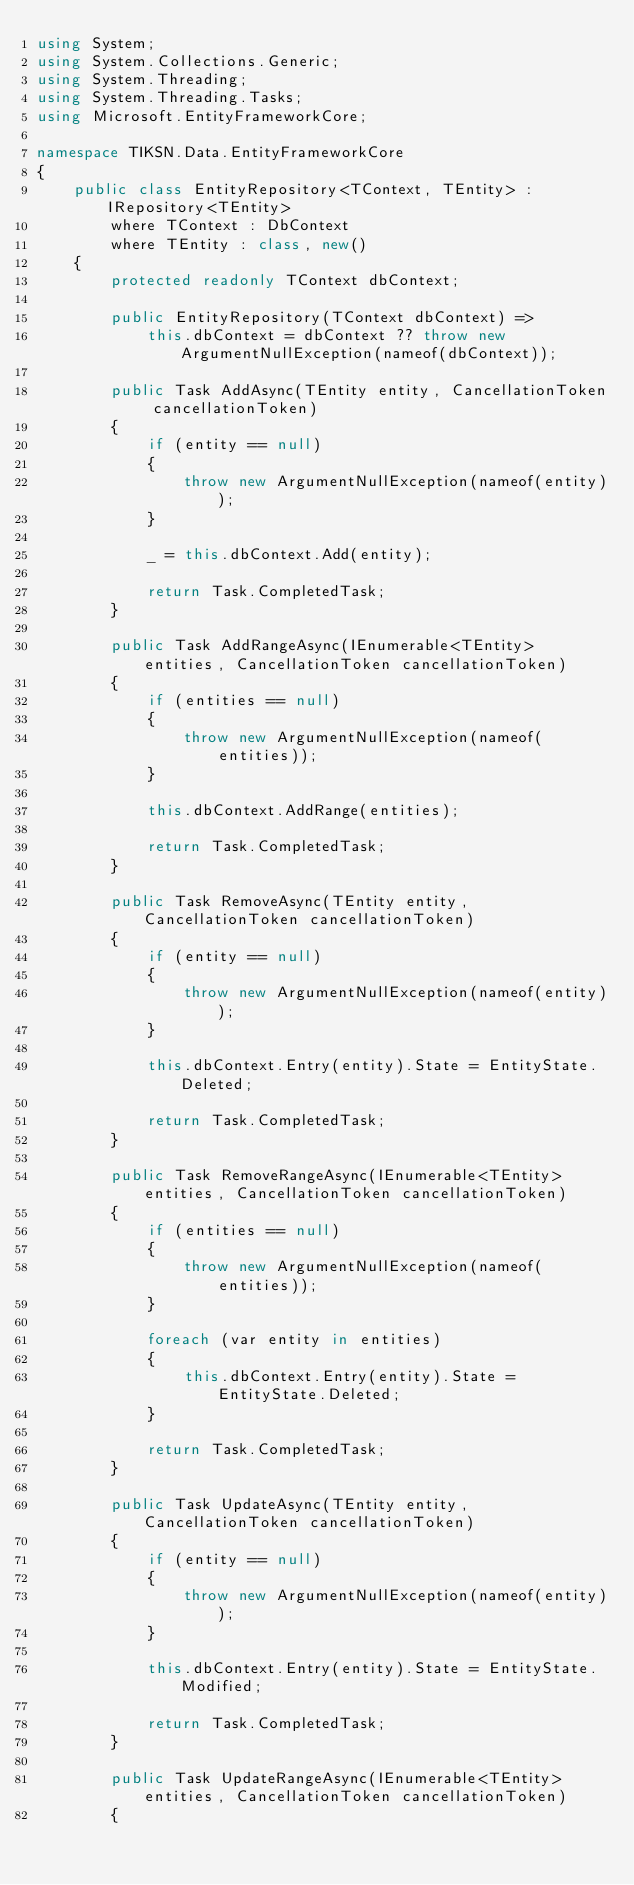Convert code to text. <code><loc_0><loc_0><loc_500><loc_500><_C#_>using System;
using System.Collections.Generic;
using System.Threading;
using System.Threading.Tasks;
using Microsoft.EntityFrameworkCore;

namespace TIKSN.Data.EntityFrameworkCore
{
    public class EntityRepository<TContext, TEntity> : IRepository<TEntity>
        where TContext : DbContext
        where TEntity : class, new()
    {
        protected readonly TContext dbContext;

        public EntityRepository(TContext dbContext) =>
            this.dbContext = dbContext ?? throw new ArgumentNullException(nameof(dbContext));

        public Task AddAsync(TEntity entity, CancellationToken cancellationToken)
        {
            if (entity == null)
            {
                throw new ArgumentNullException(nameof(entity));
            }

            _ = this.dbContext.Add(entity);

            return Task.CompletedTask;
        }

        public Task AddRangeAsync(IEnumerable<TEntity> entities, CancellationToken cancellationToken)
        {
            if (entities == null)
            {
                throw new ArgumentNullException(nameof(entities));
            }

            this.dbContext.AddRange(entities);

            return Task.CompletedTask;
        }

        public Task RemoveAsync(TEntity entity, CancellationToken cancellationToken)
        {
            if (entity == null)
            {
                throw new ArgumentNullException(nameof(entity));
            }

            this.dbContext.Entry(entity).State = EntityState.Deleted;

            return Task.CompletedTask;
        }

        public Task RemoveRangeAsync(IEnumerable<TEntity> entities, CancellationToken cancellationToken)
        {
            if (entities == null)
            {
                throw new ArgumentNullException(nameof(entities));
            }

            foreach (var entity in entities)
            {
                this.dbContext.Entry(entity).State = EntityState.Deleted;
            }

            return Task.CompletedTask;
        }

        public Task UpdateAsync(TEntity entity, CancellationToken cancellationToken)
        {
            if (entity == null)
            {
                throw new ArgumentNullException(nameof(entity));
            }

            this.dbContext.Entry(entity).State = EntityState.Modified;

            return Task.CompletedTask;
        }

        public Task UpdateRangeAsync(IEnumerable<TEntity> entities, CancellationToken cancellationToken)
        {</code> 